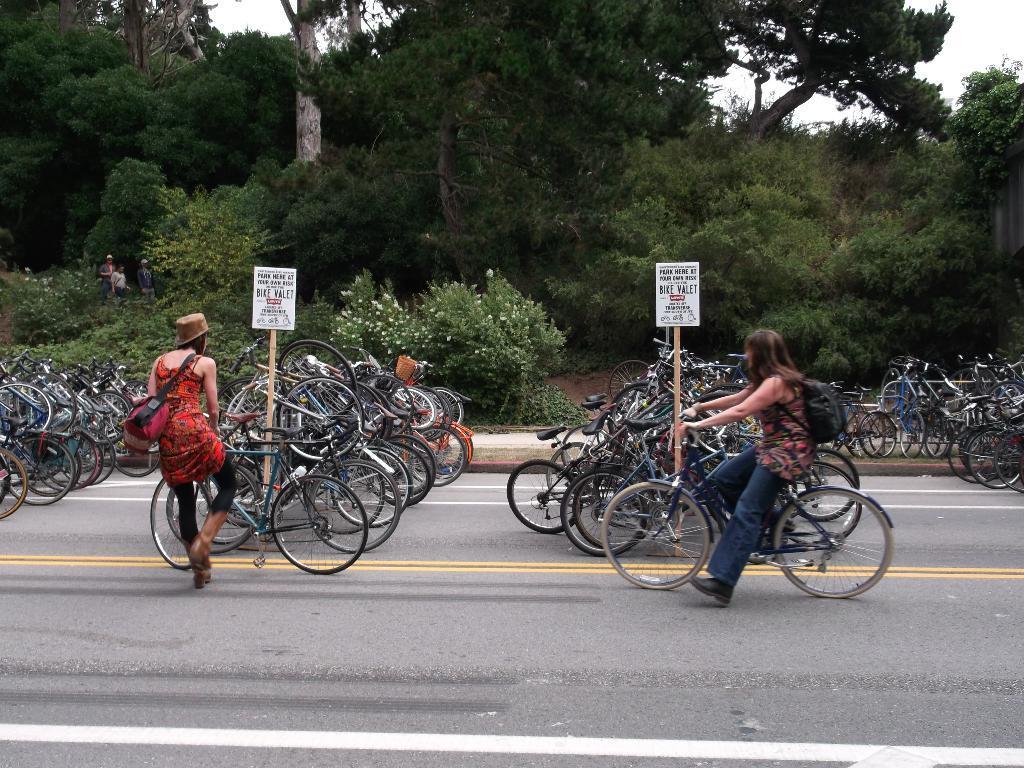Describe this image in one or two sentences. In this picture there are trees at the center of the image and it seems to be bicycle parking area and there are two girls they are also parking the bicycles in the area, it is a day time. 